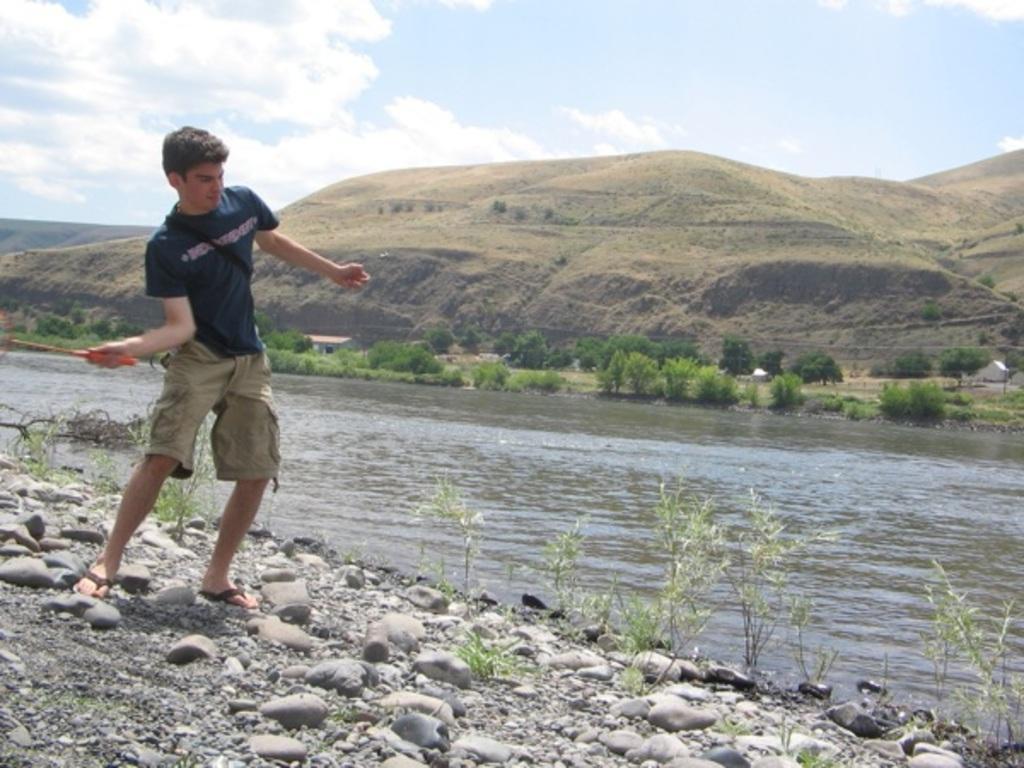Could you give a brief overview of what you see in this image? In this image I can see the person standing and holding some object. The person is wearing blue and cream color dress. In the background I can see the water, few plants in green color, mountains and the sky is in white color. 